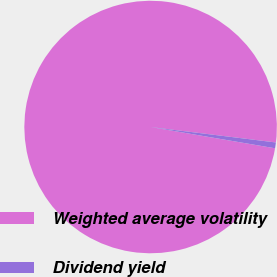Convert chart to OTSL. <chart><loc_0><loc_0><loc_500><loc_500><pie_chart><fcel>Weighted average volatility<fcel>Dividend yield<nl><fcel>99.26%<fcel>0.74%<nl></chart> 